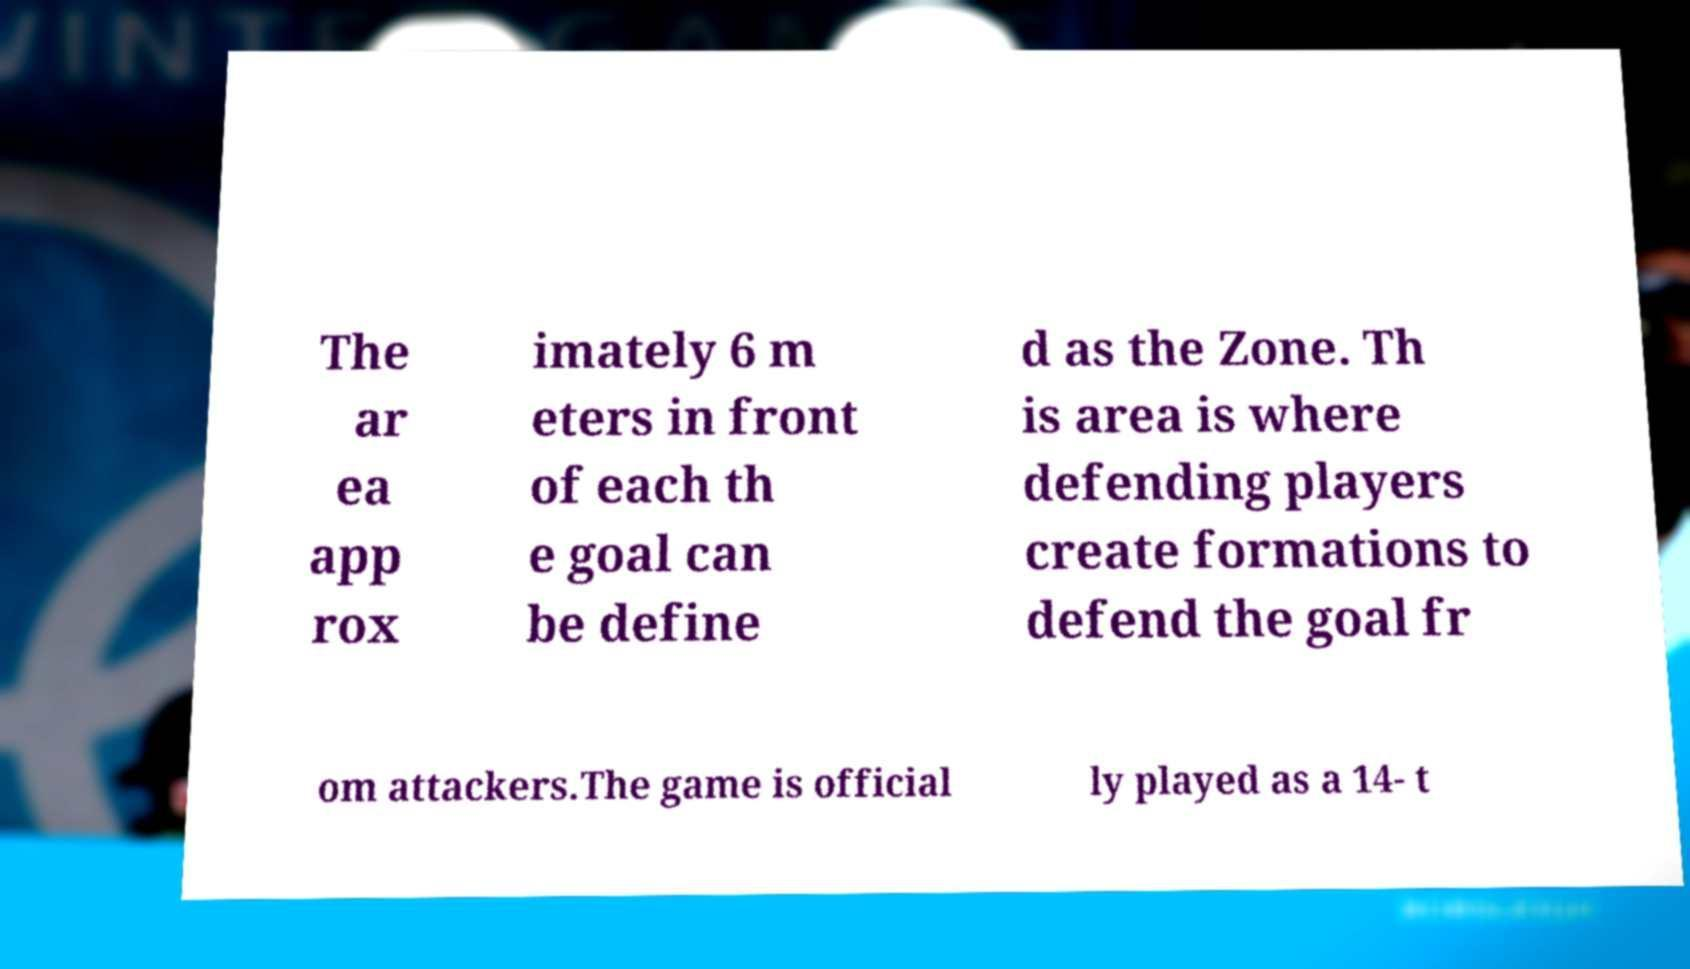Please identify and transcribe the text found in this image. The ar ea app rox imately 6 m eters in front of each th e goal can be define d as the Zone. Th is area is where defending players create formations to defend the goal fr om attackers.The game is official ly played as a 14- t 